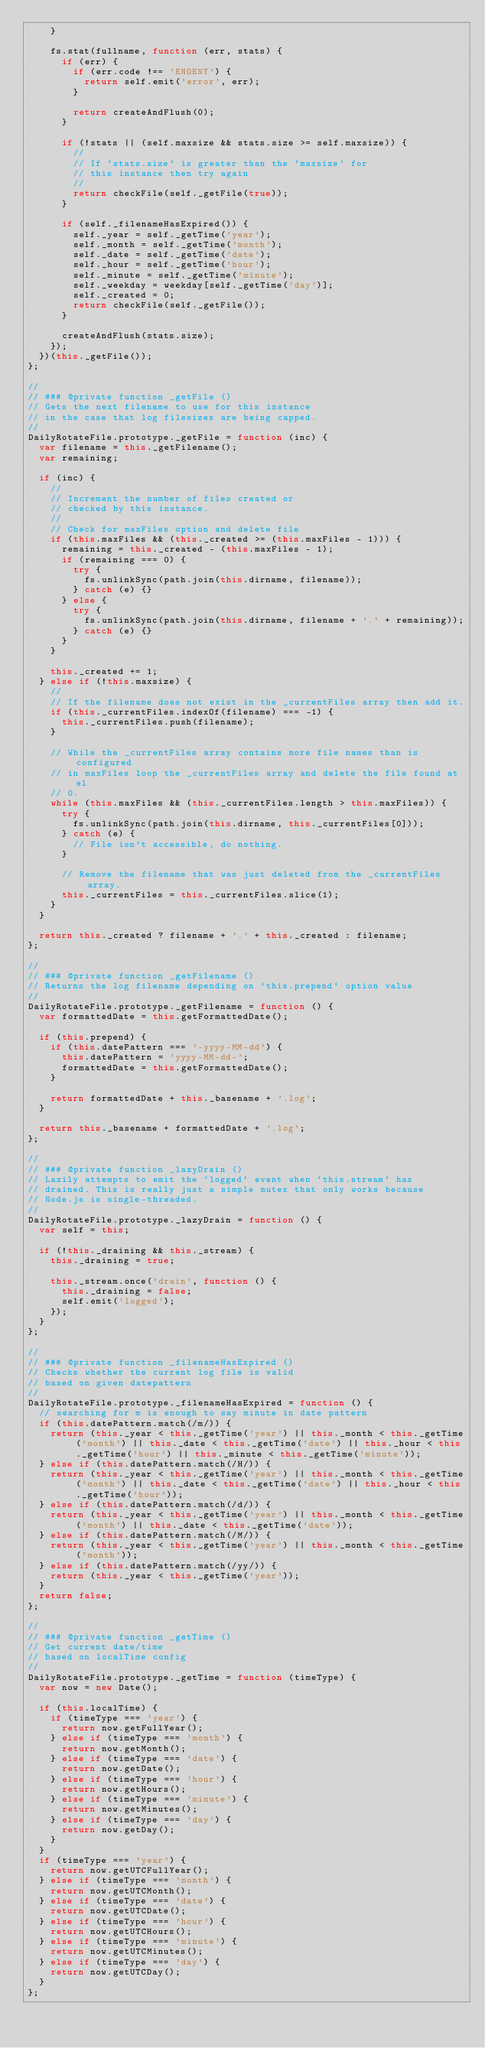<code> <loc_0><loc_0><loc_500><loc_500><_JavaScript_>    }

    fs.stat(fullname, function (err, stats) {
      if (err) {
        if (err.code !== 'ENOENT') {
          return self.emit('error', err);
        }

        return createAndFlush(0);
      }

      if (!stats || (self.maxsize && stats.size >= self.maxsize)) {
        //
        // If `stats.size` is greater than the `maxsize` for
        // this instance then try again
        //
        return checkFile(self._getFile(true));
      }

      if (self._filenameHasExpired()) {
        self._year = self._getTime('year');
        self._month = self._getTime('month');
        self._date = self._getTime('date');
        self._hour = self._getTime('hour');
        self._minute = self._getTime('minute');
        self._weekday = weekday[self._getTime('day')];
        self._created = 0;
        return checkFile(self._getFile());
      }

      createAndFlush(stats.size);
    });
  })(this._getFile());
};

//
// ### @private function _getFile ()
// Gets the next filename to use for this instance
// in the case that log filesizes are being capped.
//
DailyRotateFile.prototype._getFile = function (inc) {
  var filename = this._getFilename();
  var remaining;

  if (inc) {
    //
    // Increment the number of files created or
    // checked by this instance.
    //
    // Check for maxFiles option and delete file
    if (this.maxFiles && (this._created >= (this.maxFiles - 1))) {
      remaining = this._created - (this.maxFiles - 1);
      if (remaining === 0) {
        try {
          fs.unlinkSync(path.join(this.dirname, filename));
        } catch (e) {}
      } else {
        try {
          fs.unlinkSync(path.join(this.dirname, filename + '.' + remaining));
        } catch (e) {}
      }
    }

    this._created += 1;
  } else if (!this.maxsize) {
    //
    // If the filename does not exist in the _currentFiles array then add it.
    if (this._currentFiles.indexOf(filename) === -1) {
      this._currentFiles.push(filename);
    }

    // While the _currentFiles array contains more file names than is configured
    // in maxFiles loop the _currentFiles array and delete the file found at el
    // 0.
    while (this.maxFiles && (this._currentFiles.length > this.maxFiles)) {
      try {
        fs.unlinkSync(path.join(this.dirname, this._currentFiles[0]));
      } catch (e) {
        // File isn't accessible, do nothing.
      }

      // Remove the filename that was just deleted from the _currentFiles array.
      this._currentFiles = this._currentFiles.slice(1);
    }
  }

  return this._created ? filename + '.' + this._created : filename;
};

//
// ### @private function _getFilename ()
// Returns the log filename depending on `this.prepend` option value
//
DailyRotateFile.prototype._getFilename = function () {
  var formattedDate = this.getFormattedDate();

  if (this.prepend) {
    if (this.datePattern === '-yyyy-MM-dd') {
      this.datePattern = 'yyyy-MM-dd-';
      formattedDate = this.getFormattedDate();
    }

    return formattedDate + this._basename + '.log';
  }

  return this._basename + formattedDate + '.log';
};

//
// ### @private function _lazyDrain ()
// Lazily attempts to emit the `logged` event when `this.stream` has
// drained. This is really just a simple mutex that only works because
// Node.js is single-threaded.
//
DailyRotateFile.prototype._lazyDrain = function () {
  var self = this;

  if (!this._draining && this._stream) {
    this._draining = true;

    this._stream.once('drain', function () {
      this._draining = false;
      self.emit('logged');
    });
  }
};

//
// ### @private function _filenameHasExpired ()
// Checks whether the current log file is valid
// based on given datepattern
//
DailyRotateFile.prototype._filenameHasExpired = function () {
  // searching for m is enough to say minute in date pattern
  if (this.datePattern.match(/m/)) {
    return (this._year < this._getTime('year') || this._month < this._getTime('month') || this._date < this._getTime('date') || this._hour < this._getTime('hour') || this._minute < this._getTime('minute'));
  } else if (this.datePattern.match(/H/)) {
    return (this._year < this._getTime('year') || this._month < this._getTime('month') || this._date < this._getTime('date') || this._hour < this._getTime('hour'));
  } else if (this.datePattern.match(/d/)) {
    return (this._year < this._getTime('year') || this._month < this._getTime('month') || this._date < this._getTime('date'));
  } else if (this.datePattern.match(/M/)) {
    return (this._year < this._getTime('year') || this._month < this._getTime('month'));
  } else if (this.datePattern.match(/yy/)) {
    return (this._year < this._getTime('year'));
  }
  return false;
};

//
// ### @private function _getTime ()
// Get current date/time
// based on localTime config
//
DailyRotateFile.prototype._getTime = function (timeType) {
  var now = new Date();

  if (this.localTime) {
    if (timeType === 'year') {
      return now.getFullYear();
    } else if (timeType === 'month') {
      return now.getMonth();
    } else if (timeType === 'date') {
      return now.getDate();
    } else if (timeType === 'hour') {
      return now.getHours();
    } else if (timeType === 'minute') {
      return now.getMinutes();
    } else if (timeType === 'day') {
      return now.getDay();
    }
  }
  if (timeType === 'year') {
    return now.getUTCFullYear();
  } else if (timeType === 'month') {
    return now.getUTCMonth();
  } else if (timeType === 'date') {
    return now.getUTCDate();
  } else if (timeType === 'hour') {
    return now.getUTCHours();
  } else if (timeType === 'minute') {
    return now.getUTCMinutes();
  } else if (timeType === 'day') {
    return now.getUTCDay();
  }
};
</code> 